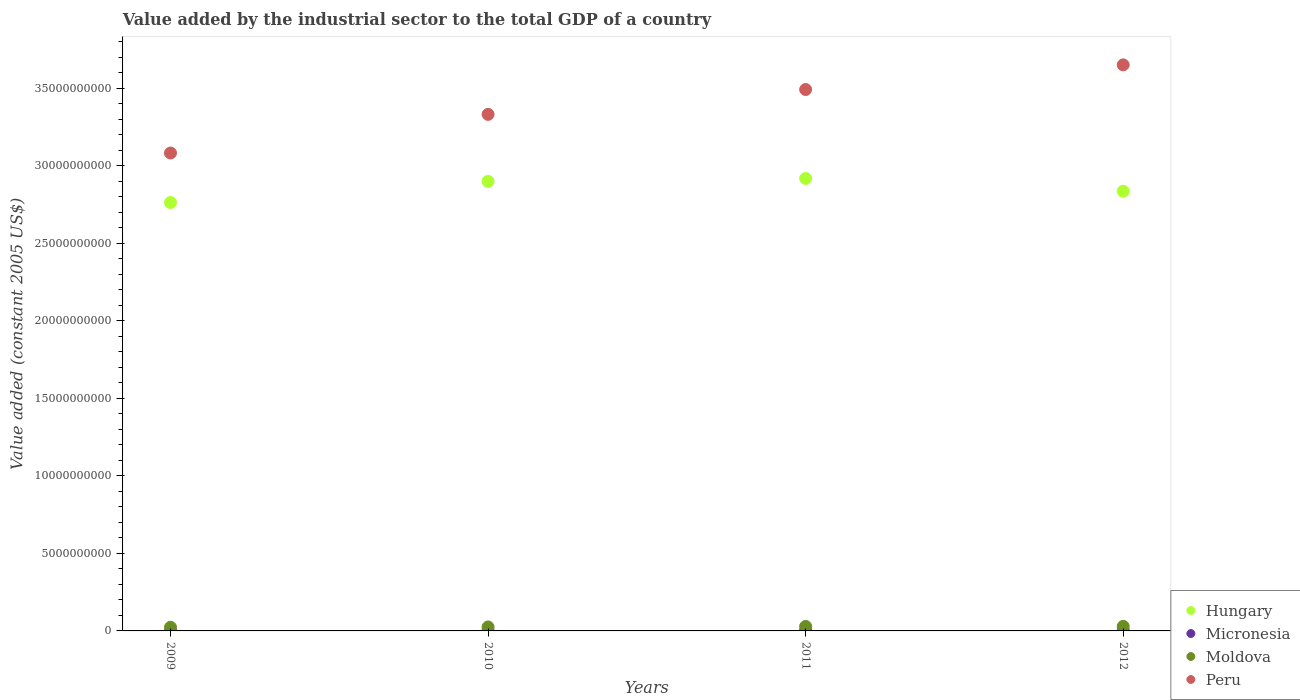What is the value added by the industrial sector in Micronesia in 2012?
Make the answer very short. 1.86e+07. Across all years, what is the maximum value added by the industrial sector in Micronesia?
Provide a short and direct response. 1.86e+07. Across all years, what is the minimum value added by the industrial sector in Micronesia?
Offer a terse response. 1.41e+07. In which year was the value added by the industrial sector in Peru minimum?
Keep it short and to the point. 2009. What is the total value added by the industrial sector in Peru in the graph?
Provide a short and direct response. 1.36e+11. What is the difference between the value added by the industrial sector in Hungary in 2009 and that in 2010?
Provide a succinct answer. -1.37e+09. What is the difference between the value added by the industrial sector in Hungary in 2011 and the value added by the industrial sector in Moldova in 2012?
Offer a very short reply. 2.89e+1. What is the average value added by the industrial sector in Peru per year?
Offer a very short reply. 3.39e+1. In the year 2012, what is the difference between the value added by the industrial sector in Hungary and value added by the industrial sector in Moldova?
Offer a terse response. 2.81e+1. What is the ratio of the value added by the industrial sector in Micronesia in 2010 to that in 2012?
Offer a terse response. 0.88. Is the value added by the industrial sector in Moldova in 2010 less than that in 2011?
Offer a terse response. Yes. What is the difference between the highest and the second highest value added by the industrial sector in Peru?
Offer a very short reply. 1.59e+09. What is the difference between the highest and the lowest value added by the industrial sector in Micronesia?
Keep it short and to the point. 4.49e+06. In how many years, is the value added by the industrial sector in Micronesia greater than the average value added by the industrial sector in Micronesia taken over all years?
Your answer should be compact. 2. Is the value added by the industrial sector in Moldova strictly greater than the value added by the industrial sector in Hungary over the years?
Give a very brief answer. No. How many years are there in the graph?
Offer a very short reply. 4. Does the graph contain any zero values?
Keep it short and to the point. No. How many legend labels are there?
Keep it short and to the point. 4. What is the title of the graph?
Your response must be concise. Value added by the industrial sector to the total GDP of a country. Does "Slovenia" appear as one of the legend labels in the graph?
Provide a short and direct response. No. What is the label or title of the X-axis?
Your answer should be very brief. Years. What is the label or title of the Y-axis?
Your response must be concise. Value added (constant 2005 US$). What is the Value added (constant 2005 US$) in Hungary in 2009?
Keep it short and to the point. 2.76e+1. What is the Value added (constant 2005 US$) of Micronesia in 2009?
Provide a short and direct response. 1.41e+07. What is the Value added (constant 2005 US$) of Moldova in 2009?
Your answer should be compact. 2.37e+08. What is the Value added (constant 2005 US$) of Peru in 2009?
Your answer should be very brief. 3.08e+1. What is the Value added (constant 2005 US$) in Hungary in 2010?
Your answer should be compact. 2.90e+1. What is the Value added (constant 2005 US$) in Micronesia in 2010?
Provide a succinct answer. 1.64e+07. What is the Value added (constant 2005 US$) of Moldova in 2010?
Your answer should be compact. 2.56e+08. What is the Value added (constant 2005 US$) in Peru in 2010?
Your response must be concise. 3.33e+1. What is the Value added (constant 2005 US$) of Hungary in 2011?
Your response must be concise. 2.92e+1. What is the Value added (constant 2005 US$) in Micronesia in 2011?
Keep it short and to the point. 1.85e+07. What is the Value added (constant 2005 US$) in Moldova in 2011?
Keep it short and to the point. 2.91e+08. What is the Value added (constant 2005 US$) of Peru in 2011?
Make the answer very short. 3.49e+1. What is the Value added (constant 2005 US$) in Hungary in 2012?
Your answer should be very brief. 2.84e+1. What is the Value added (constant 2005 US$) in Micronesia in 2012?
Provide a succinct answer. 1.86e+07. What is the Value added (constant 2005 US$) in Moldova in 2012?
Give a very brief answer. 2.94e+08. What is the Value added (constant 2005 US$) in Peru in 2012?
Provide a succinct answer. 3.65e+1. Across all years, what is the maximum Value added (constant 2005 US$) of Hungary?
Your answer should be compact. 2.92e+1. Across all years, what is the maximum Value added (constant 2005 US$) of Micronesia?
Offer a terse response. 1.86e+07. Across all years, what is the maximum Value added (constant 2005 US$) in Moldova?
Ensure brevity in your answer.  2.94e+08. Across all years, what is the maximum Value added (constant 2005 US$) of Peru?
Offer a terse response. 3.65e+1. Across all years, what is the minimum Value added (constant 2005 US$) of Hungary?
Offer a very short reply. 2.76e+1. Across all years, what is the minimum Value added (constant 2005 US$) of Micronesia?
Give a very brief answer. 1.41e+07. Across all years, what is the minimum Value added (constant 2005 US$) of Moldova?
Your response must be concise. 2.37e+08. Across all years, what is the minimum Value added (constant 2005 US$) in Peru?
Keep it short and to the point. 3.08e+1. What is the total Value added (constant 2005 US$) of Hungary in the graph?
Your response must be concise. 1.14e+11. What is the total Value added (constant 2005 US$) in Micronesia in the graph?
Offer a very short reply. 6.76e+07. What is the total Value added (constant 2005 US$) in Moldova in the graph?
Your answer should be compact. 1.08e+09. What is the total Value added (constant 2005 US$) of Peru in the graph?
Give a very brief answer. 1.36e+11. What is the difference between the Value added (constant 2005 US$) in Hungary in 2009 and that in 2010?
Your response must be concise. -1.37e+09. What is the difference between the Value added (constant 2005 US$) of Micronesia in 2009 and that in 2010?
Provide a short and direct response. -2.29e+06. What is the difference between the Value added (constant 2005 US$) in Moldova in 2009 and that in 2010?
Offer a terse response. -1.97e+07. What is the difference between the Value added (constant 2005 US$) of Peru in 2009 and that in 2010?
Offer a terse response. -2.49e+09. What is the difference between the Value added (constant 2005 US$) of Hungary in 2009 and that in 2011?
Your answer should be very brief. -1.55e+09. What is the difference between the Value added (constant 2005 US$) in Micronesia in 2009 and that in 2011?
Give a very brief answer. -4.39e+06. What is the difference between the Value added (constant 2005 US$) of Moldova in 2009 and that in 2011?
Provide a short and direct response. -5.45e+07. What is the difference between the Value added (constant 2005 US$) of Peru in 2009 and that in 2011?
Ensure brevity in your answer.  -4.09e+09. What is the difference between the Value added (constant 2005 US$) in Hungary in 2009 and that in 2012?
Provide a short and direct response. -7.30e+08. What is the difference between the Value added (constant 2005 US$) in Micronesia in 2009 and that in 2012?
Your answer should be compact. -4.49e+06. What is the difference between the Value added (constant 2005 US$) of Moldova in 2009 and that in 2012?
Offer a very short reply. -5.69e+07. What is the difference between the Value added (constant 2005 US$) in Peru in 2009 and that in 2012?
Offer a very short reply. -5.68e+09. What is the difference between the Value added (constant 2005 US$) of Hungary in 2010 and that in 2011?
Offer a terse response. -1.85e+08. What is the difference between the Value added (constant 2005 US$) in Micronesia in 2010 and that in 2011?
Your answer should be very brief. -2.11e+06. What is the difference between the Value added (constant 2005 US$) of Moldova in 2010 and that in 2011?
Provide a short and direct response. -3.47e+07. What is the difference between the Value added (constant 2005 US$) of Peru in 2010 and that in 2011?
Your answer should be very brief. -1.60e+09. What is the difference between the Value added (constant 2005 US$) in Hungary in 2010 and that in 2012?
Give a very brief answer. 6.35e+08. What is the difference between the Value added (constant 2005 US$) of Micronesia in 2010 and that in 2012?
Offer a terse response. -2.20e+06. What is the difference between the Value added (constant 2005 US$) in Moldova in 2010 and that in 2012?
Give a very brief answer. -3.72e+07. What is the difference between the Value added (constant 2005 US$) of Peru in 2010 and that in 2012?
Provide a succinct answer. -3.19e+09. What is the difference between the Value added (constant 2005 US$) in Hungary in 2011 and that in 2012?
Your answer should be compact. 8.20e+08. What is the difference between the Value added (constant 2005 US$) in Micronesia in 2011 and that in 2012?
Provide a succinct answer. -9.15e+04. What is the difference between the Value added (constant 2005 US$) in Moldova in 2011 and that in 2012?
Give a very brief answer. -2.47e+06. What is the difference between the Value added (constant 2005 US$) of Peru in 2011 and that in 2012?
Your response must be concise. -1.59e+09. What is the difference between the Value added (constant 2005 US$) in Hungary in 2009 and the Value added (constant 2005 US$) in Micronesia in 2010?
Offer a very short reply. 2.76e+1. What is the difference between the Value added (constant 2005 US$) in Hungary in 2009 and the Value added (constant 2005 US$) in Moldova in 2010?
Provide a succinct answer. 2.74e+1. What is the difference between the Value added (constant 2005 US$) of Hungary in 2009 and the Value added (constant 2005 US$) of Peru in 2010?
Give a very brief answer. -5.69e+09. What is the difference between the Value added (constant 2005 US$) in Micronesia in 2009 and the Value added (constant 2005 US$) in Moldova in 2010?
Your response must be concise. -2.42e+08. What is the difference between the Value added (constant 2005 US$) of Micronesia in 2009 and the Value added (constant 2005 US$) of Peru in 2010?
Your answer should be compact. -3.33e+1. What is the difference between the Value added (constant 2005 US$) of Moldova in 2009 and the Value added (constant 2005 US$) of Peru in 2010?
Your answer should be very brief. -3.31e+1. What is the difference between the Value added (constant 2005 US$) in Hungary in 2009 and the Value added (constant 2005 US$) in Micronesia in 2011?
Your response must be concise. 2.76e+1. What is the difference between the Value added (constant 2005 US$) of Hungary in 2009 and the Value added (constant 2005 US$) of Moldova in 2011?
Offer a very short reply. 2.73e+1. What is the difference between the Value added (constant 2005 US$) in Hungary in 2009 and the Value added (constant 2005 US$) in Peru in 2011?
Keep it short and to the point. -7.29e+09. What is the difference between the Value added (constant 2005 US$) in Micronesia in 2009 and the Value added (constant 2005 US$) in Moldova in 2011?
Your answer should be very brief. -2.77e+08. What is the difference between the Value added (constant 2005 US$) of Micronesia in 2009 and the Value added (constant 2005 US$) of Peru in 2011?
Keep it short and to the point. -3.49e+1. What is the difference between the Value added (constant 2005 US$) of Moldova in 2009 and the Value added (constant 2005 US$) of Peru in 2011?
Provide a short and direct response. -3.47e+1. What is the difference between the Value added (constant 2005 US$) in Hungary in 2009 and the Value added (constant 2005 US$) in Micronesia in 2012?
Offer a terse response. 2.76e+1. What is the difference between the Value added (constant 2005 US$) in Hungary in 2009 and the Value added (constant 2005 US$) in Moldova in 2012?
Offer a terse response. 2.73e+1. What is the difference between the Value added (constant 2005 US$) in Hungary in 2009 and the Value added (constant 2005 US$) in Peru in 2012?
Provide a succinct answer. -8.88e+09. What is the difference between the Value added (constant 2005 US$) of Micronesia in 2009 and the Value added (constant 2005 US$) of Moldova in 2012?
Offer a very short reply. -2.80e+08. What is the difference between the Value added (constant 2005 US$) in Micronesia in 2009 and the Value added (constant 2005 US$) in Peru in 2012?
Make the answer very short. -3.65e+1. What is the difference between the Value added (constant 2005 US$) in Moldova in 2009 and the Value added (constant 2005 US$) in Peru in 2012?
Give a very brief answer. -3.63e+1. What is the difference between the Value added (constant 2005 US$) in Hungary in 2010 and the Value added (constant 2005 US$) in Micronesia in 2011?
Your answer should be compact. 2.90e+1. What is the difference between the Value added (constant 2005 US$) in Hungary in 2010 and the Value added (constant 2005 US$) in Moldova in 2011?
Keep it short and to the point. 2.87e+1. What is the difference between the Value added (constant 2005 US$) of Hungary in 2010 and the Value added (constant 2005 US$) of Peru in 2011?
Keep it short and to the point. -5.92e+09. What is the difference between the Value added (constant 2005 US$) of Micronesia in 2010 and the Value added (constant 2005 US$) of Moldova in 2011?
Give a very brief answer. -2.75e+08. What is the difference between the Value added (constant 2005 US$) of Micronesia in 2010 and the Value added (constant 2005 US$) of Peru in 2011?
Ensure brevity in your answer.  -3.49e+1. What is the difference between the Value added (constant 2005 US$) in Moldova in 2010 and the Value added (constant 2005 US$) in Peru in 2011?
Your answer should be very brief. -3.47e+1. What is the difference between the Value added (constant 2005 US$) of Hungary in 2010 and the Value added (constant 2005 US$) of Micronesia in 2012?
Provide a succinct answer. 2.90e+1. What is the difference between the Value added (constant 2005 US$) of Hungary in 2010 and the Value added (constant 2005 US$) of Moldova in 2012?
Ensure brevity in your answer.  2.87e+1. What is the difference between the Value added (constant 2005 US$) in Hungary in 2010 and the Value added (constant 2005 US$) in Peru in 2012?
Provide a short and direct response. -7.51e+09. What is the difference between the Value added (constant 2005 US$) of Micronesia in 2010 and the Value added (constant 2005 US$) of Moldova in 2012?
Your response must be concise. -2.77e+08. What is the difference between the Value added (constant 2005 US$) in Micronesia in 2010 and the Value added (constant 2005 US$) in Peru in 2012?
Your answer should be very brief. -3.65e+1. What is the difference between the Value added (constant 2005 US$) of Moldova in 2010 and the Value added (constant 2005 US$) of Peru in 2012?
Keep it short and to the point. -3.63e+1. What is the difference between the Value added (constant 2005 US$) in Hungary in 2011 and the Value added (constant 2005 US$) in Micronesia in 2012?
Keep it short and to the point. 2.92e+1. What is the difference between the Value added (constant 2005 US$) of Hungary in 2011 and the Value added (constant 2005 US$) of Moldova in 2012?
Keep it short and to the point. 2.89e+1. What is the difference between the Value added (constant 2005 US$) of Hungary in 2011 and the Value added (constant 2005 US$) of Peru in 2012?
Offer a terse response. -7.33e+09. What is the difference between the Value added (constant 2005 US$) in Micronesia in 2011 and the Value added (constant 2005 US$) in Moldova in 2012?
Ensure brevity in your answer.  -2.75e+08. What is the difference between the Value added (constant 2005 US$) of Micronesia in 2011 and the Value added (constant 2005 US$) of Peru in 2012?
Offer a terse response. -3.65e+1. What is the difference between the Value added (constant 2005 US$) in Moldova in 2011 and the Value added (constant 2005 US$) in Peru in 2012?
Offer a very short reply. -3.62e+1. What is the average Value added (constant 2005 US$) in Hungary per year?
Make the answer very short. 2.85e+1. What is the average Value added (constant 2005 US$) of Micronesia per year?
Offer a very short reply. 1.69e+07. What is the average Value added (constant 2005 US$) of Moldova per year?
Your answer should be very brief. 2.70e+08. What is the average Value added (constant 2005 US$) in Peru per year?
Offer a terse response. 3.39e+1. In the year 2009, what is the difference between the Value added (constant 2005 US$) of Hungary and Value added (constant 2005 US$) of Micronesia?
Keep it short and to the point. 2.76e+1. In the year 2009, what is the difference between the Value added (constant 2005 US$) of Hungary and Value added (constant 2005 US$) of Moldova?
Offer a terse response. 2.74e+1. In the year 2009, what is the difference between the Value added (constant 2005 US$) of Hungary and Value added (constant 2005 US$) of Peru?
Offer a very short reply. -3.19e+09. In the year 2009, what is the difference between the Value added (constant 2005 US$) in Micronesia and Value added (constant 2005 US$) in Moldova?
Keep it short and to the point. -2.23e+08. In the year 2009, what is the difference between the Value added (constant 2005 US$) in Micronesia and Value added (constant 2005 US$) in Peru?
Your answer should be compact. -3.08e+1. In the year 2009, what is the difference between the Value added (constant 2005 US$) in Moldova and Value added (constant 2005 US$) in Peru?
Give a very brief answer. -3.06e+1. In the year 2010, what is the difference between the Value added (constant 2005 US$) of Hungary and Value added (constant 2005 US$) of Micronesia?
Make the answer very short. 2.90e+1. In the year 2010, what is the difference between the Value added (constant 2005 US$) in Hungary and Value added (constant 2005 US$) in Moldova?
Provide a short and direct response. 2.87e+1. In the year 2010, what is the difference between the Value added (constant 2005 US$) of Hungary and Value added (constant 2005 US$) of Peru?
Your answer should be compact. -4.32e+09. In the year 2010, what is the difference between the Value added (constant 2005 US$) of Micronesia and Value added (constant 2005 US$) of Moldova?
Give a very brief answer. -2.40e+08. In the year 2010, what is the difference between the Value added (constant 2005 US$) of Micronesia and Value added (constant 2005 US$) of Peru?
Provide a short and direct response. -3.33e+1. In the year 2010, what is the difference between the Value added (constant 2005 US$) in Moldova and Value added (constant 2005 US$) in Peru?
Your answer should be very brief. -3.31e+1. In the year 2011, what is the difference between the Value added (constant 2005 US$) in Hungary and Value added (constant 2005 US$) in Micronesia?
Provide a succinct answer. 2.92e+1. In the year 2011, what is the difference between the Value added (constant 2005 US$) of Hungary and Value added (constant 2005 US$) of Moldova?
Keep it short and to the point. 2.89e+1. In the year 2011, what is the difference between the Value added (constant 2005 US$) of Hungary and Value added (constant 2005 US$) of Peru?
Make the answer very short. -5.74e+09. In the year 2011, what is the difference between the Value added (constant 2005 US$) in Micronesia and Value added (constant 2005 US$) in Moldova?
Offer a terse response. -2.73e+08. In the year 2011, what is the difference between the Value added (constant 2005 US$) of Micronesia and Value added (constant 2005 US$) of Peru?
Give a very brief answer. -3.49e+1. In the year 2011, what is the difference between the Value added (constant 2005 US$) in Moldova and Value added (constant 2005 US$) in Peru?
Your answer should be compact. -3.46e+1. In the year 2012, what is the difference between the Value added (constant 2005 US$) of Hungary and Value added (constant 2005 US$) of Micronesia?
Ensure brevity in your answer.  2.83e+1. In the year 2012, what is the difference between the Value added (constant 2005 US$) in Hungary and Value added (constant 2005 US$) in Moldova?
Make the answer very short. 2.81e+1. In the year 2012, what is the difference between the Value added (constant 2005 US$) of Hungary and Value added (constant 2005 US$) of Peru?
Make the answer very short. -8.15e+09. In the year 2012, what is the difference between the Value added (constant 2005 US$) in Micronesia and Value added (constant 2005 US$) in Moldova?
Give a very brief answer. -2.75e+08. In the year 2012, what is the difference between the Value added (constant 2005 US$) in Micronesia and Value added (constant 2005 US$) in Peru?
Provide a succinct answer. -3.65e+1. In the year 2012, what is the difference between the Value added (constant 2005 US$) in Moldova and Value added (constant 2005 US$) in Peru?
Make the answer very short. -3.62e+1. What is the ratio of the Value added (constant 2005 US$) of Hungary in 2009 to that in 2010?
Your response must be concise. 0.95. What is the ratio of the Value added (constant 2005 US$) in Micronesia in 2009 to that in 2010?
Offer a terse response. 0.86. What is the ratio of the Value added (constant 2005 US$) of Moldova in 2009 to that in 2010?
Your answer should be compact. 0.92. What is the ratio of the Value added (constant 2005 US$) of Peru in 2009 to that in 2010?
Offer a terse response. 0.93. What is the ratio of the Value added (constant 2005 US$) in Hungary in 2009 to that in 2011?
Your answer should be very brief. 0.95. What is the ratio of the Value added (constant 2005 US$) in Micronesia in 2009 to that in 2011?
Offer a terse response. 0.76. What is the ratio of the Value added (constant 2005 US$) of Moldova in 2009 to that in 2011?
Offer a terse response. 0.81. What is the ratio of the Value added (constant 2005 US$) in Peru in 2009 to that in 2011?
Provide a short and direct response. 0.88. What is the ratio of the Value added (constant 2005 US$) of Hungary in 2009 to that in 2012?
Provide a short and direct response. 0.97. What is the ratio of the Value added (constant 2005 US$) of Micronesia in 2009 to that in 2012?
Ensure brevity in your answer.  0.76. What is the ratio of the Value added (constant 2005 US$) in Moldova in 2009 to that in 2012?
Provide a short and direct response. 0.81. What is the ratio of the Value added (constant 2005 US$) in Peru in 2009 to that in 2012?
Provide a short and direct response. 0.84. What is the ratio of the Value added (constant 2005 US$) in Micronesia in 2010 to that in 2011?
Your answer should be very brief. 0.89. What is the ratio of the Value added (constant 2005 US$) of Moldova in 2010 to that in 2011?
Offer a very short reply. 0.88. What is the ratio of the Value added (constant 2005 US$) of Peru in 2010 to that in 2011?
Your answer should be compact. 0.95. What is the ratio of the Value added (constant 2005 US$) of Hungary in 2010 to that in 2012?
Your answer should be very brief. 1.02. What is the ratio of the Value added (constant 2005 US$) in Micronesia in 2010 to that in 2012?
Your response must be concise. 0.88. What is the ratio of the Value added (constant 2005 US$) of Moldova in 2010 to that in 2012?
Your answer should be very brief. 0.87. What is the ratio of the Value added (constant 2005 US$) in Peru in 2010 to that in 2012?
Give a very brief answer. 0.91. What is the ratio of the Value added (constant 2005 US$) of Hungary in 2011 to that in 2012?
Provide a short and direct response. 1.03. What is the ratio of the Value added (constant 2005 US$) of Moldova in 2011 to that in 2012?
Your answer should be compact. 0.99. What is the ratio of the Value added (constant 2005 US$) of Peru in 2011 to that in 2012?
Provide a succinct answer. 0.96. What is the difference between the highest and the second highest Value added (constant 2005 US$) of Hungary?
Provide a short and direct response. 1.85e+08. What is the difference between the highest and the second highest Value added (constant 2005 US$) in Micronesia?
Your answer should be compact. 9.15e+04. What is the difference between the highest and the second highest Value added (constant 2005 US$) of Moldova?
Provide a succinct answer. 2.47e+06. What is the difference between the highest and the second highest Value added (constant 2005 US$) in Peru?
Give a very brief answer. 1.59e+09. What is the difference between the highest and the lowest Value added (constant 2005 US$) in Hungary?
Keep it short and to the point. 1.55e+09. What is the difference between the highest and the lowest Value added (constant 2005 US$) of Micronesia?
Offer a very short reply. 4.49e+06. What is the difference between the highest and the lowest Value added (constant 2005 US$) in Moldova?
Your answer should be very brief. 5.69e+07. What is the difference between the highest and the lowest Value added (constant 2005 US$) of Peru?
Provide a succinct answer. 5.68e+09. 